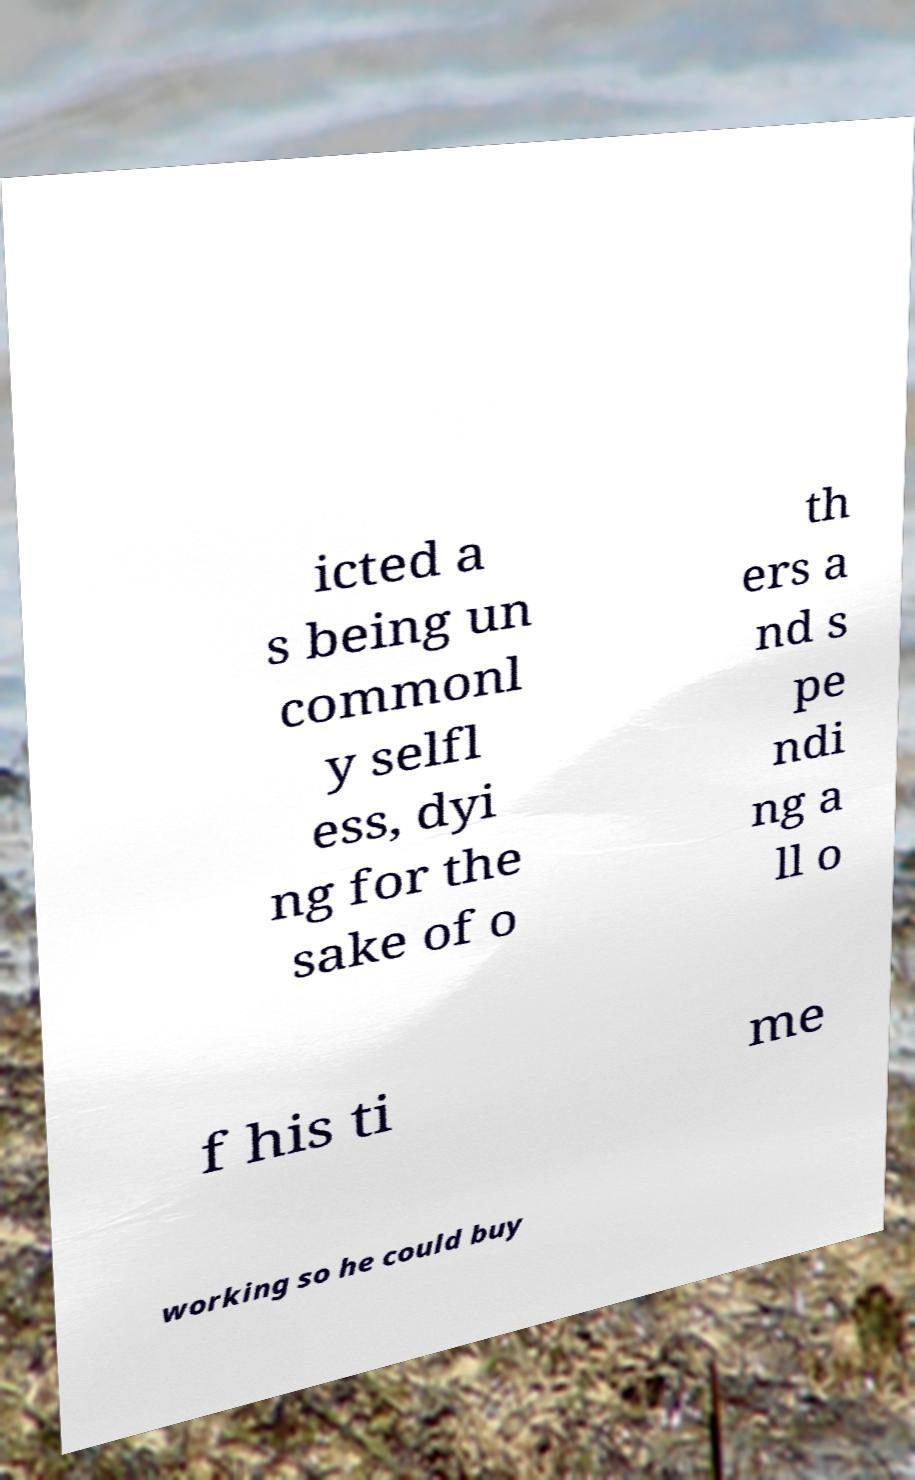For documentation purposes, I need the text within this image transcribed. Could you provide that? icted a s being un commonl y selfl ess, dyi ng for the sake of o th ers a nd s pe ndi ng a ll o f his ti me working so he could buy 